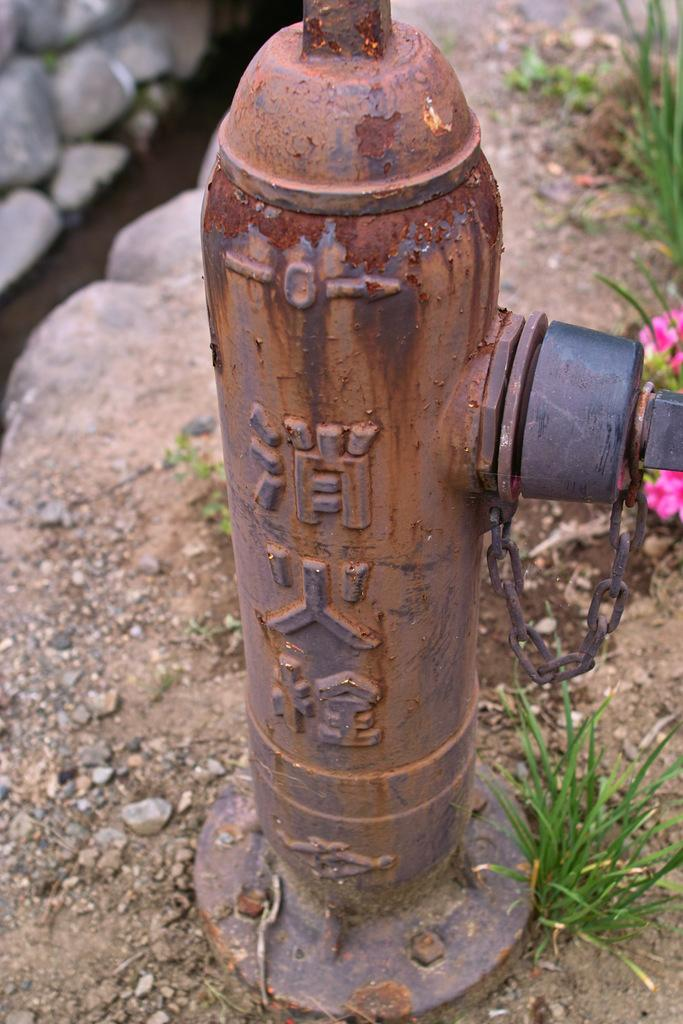What is the main object in the image? There is a water supply pole in the image. Where is the water supply pole located? The water supply pole is on the ground. What can be seen in the background of the image? There are flowers on a plant in the background of the image. What type of education can be seen in the image? There is no reference to education in the image; it features a water supply pole and flowers on a plant. 